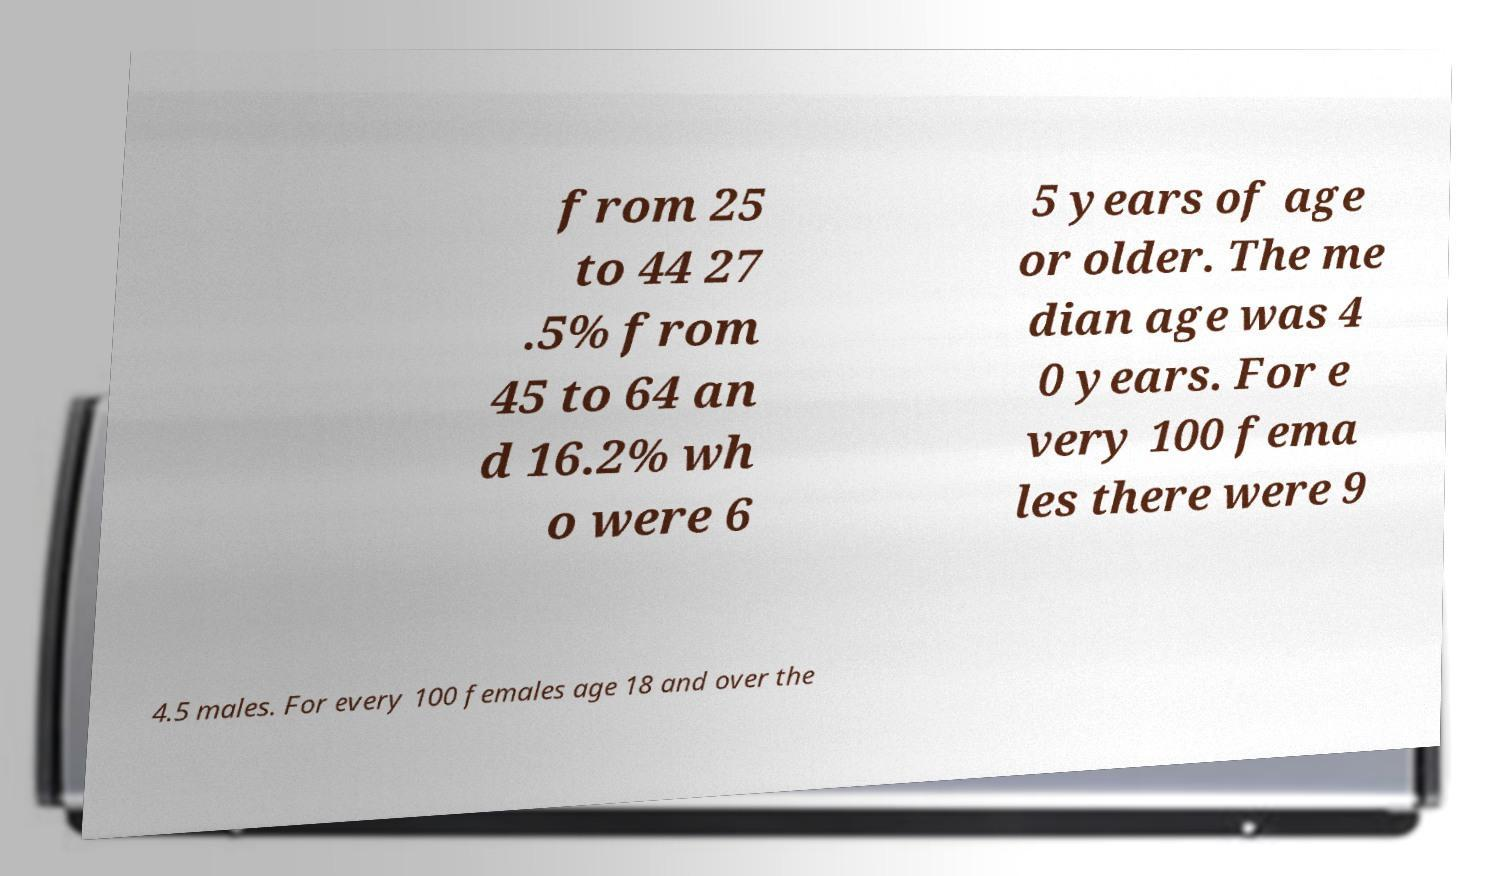There's text embedded in this image that I need extracted. Can you transcribe it verbatim? from 25 to 44 27 .5% from 45 to 64 an d 16.2% wh o were 6 5 years of age or older. The me dian age was 4 0 years. For e very 100 fema les there were 9 4.5 males. For every 100 females age 18 and over the 